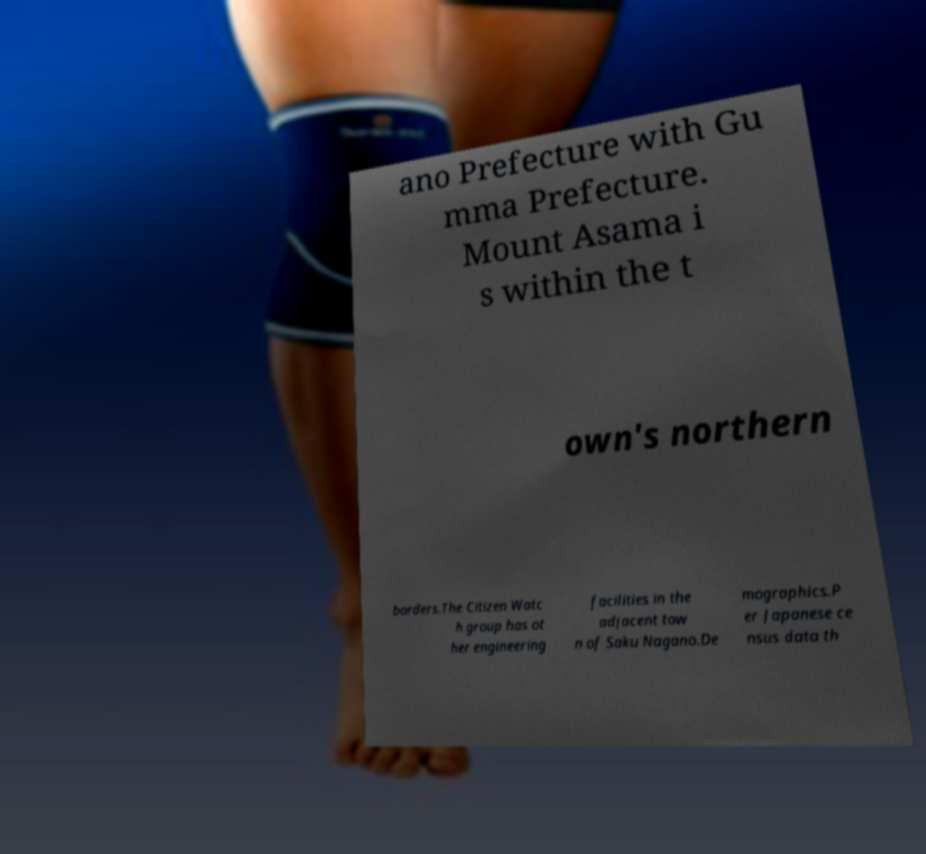What messages or text are displayed in this image? I need them in a readable, typed format. ano Prefecture with Gu mma Prefecture. Mount Asama i s within the t own's northern borders.The Citizen Watc h group has ot her engineering facilities in the adjacent tow n of Saku Nagano.De mographics.P er Japanese ce nsus data th 